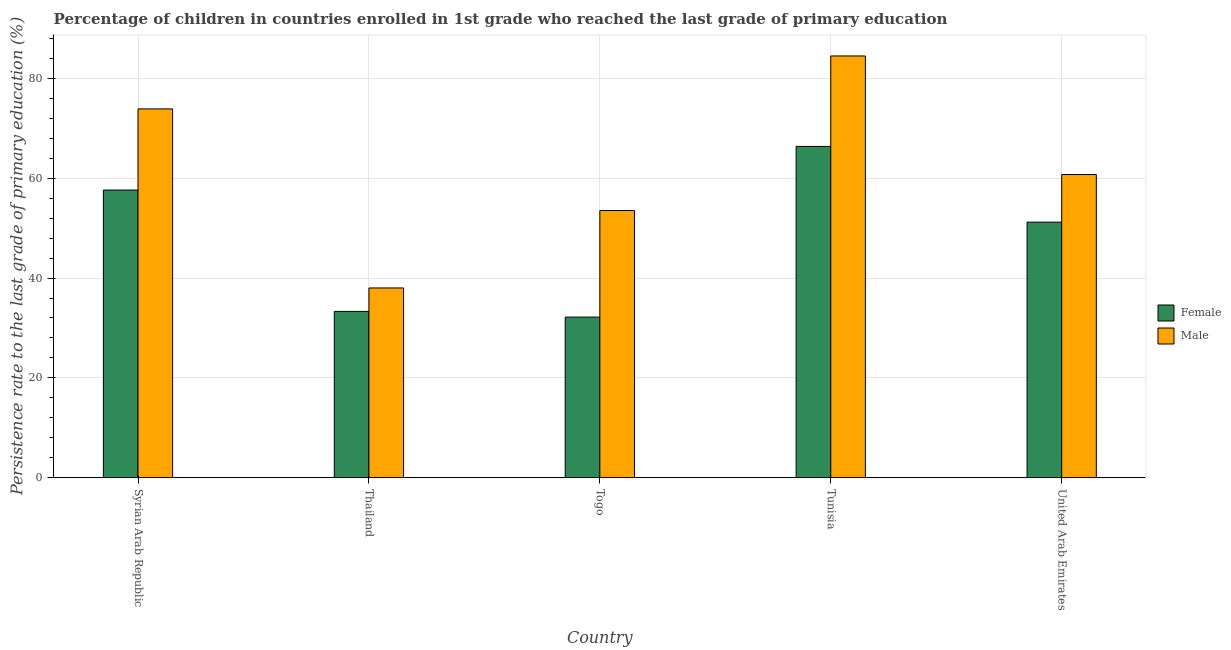How many different coloured bars are there?
Provide a short and direct response. 2. How many groups of bars are there?
Provide a succinct answer. 5. Are the number of bars on each tick of the X-axis equal?
Provide a short and direct response. Yes. What is the label of the 2nd group of bars from the left?
Your answer should be very brief. Thailand. In how many cases, is the number of bars for a given country not equal to the number of legend labels?
Ensure brevity in your answer.  0. What is the persistence rate of female students in Syrian Arab Republic?
Your answer should be very brief. 57.65. Across all countries, what is the maximum persistence rate of female students?
Ensure brevity in your answer.  66.39. Across all countries, what is the minimum persistence rate of female students?
Your answer should be very brief. 32.18. In which country was the persistence rate of male students maximum?
Make the answer very short. Tunisia. In which country was the persistence rate of female students minimum?
Your response must be concise. Togo. What is the total persistence rate of male students in the graph?
Your answer should be very brief. 310.75. What is the difference between the persistence rate of female students in Togo and that in United Arab Emirates?
Your answer should be very brief. -19.03. What is the difference between the persistence rate of female students in United Arab Emirates and the persistence rate of male students in Syrian Arab Republic?
Make the answer very short. -22.7. What is the average persistence rate of female students per country?
Your answer should be compact. 48.15. What is the difference between the persistence rate of female students and persistence rate of male students in United Arab Emirates?
Your response must be concise. -9.54. In how many countries, is the persistence rate of male students greater than 44 %?
Your answer should be compact. 4. What is the ratio of the persistence rate of female students in Togo to that in Tunisia?
Ensure brevity in your answer.  0.48. Is the persistence rate of male students in Togo less than that in Tunisia?
Your response must be concise. Yes. Is the difference between the persistence rate of male students in Togo and Tunisia greater than the difference between the persistence rate of female students in Togo and Tunisia?
Give a very brief answer. Yes. What is the difference between the highest and the second highest persistence rate of male students?
Give a very brief answer. 10.61. What is the difference between the highest and the lowest persistence rate of female students?
Your response must be concise. 34.21. In how many countries, is the persistence rate of female students greater than the average persistence rate of female students taken over all countries?
Offer a very short reply. 3. Is the sum of the persistence rate of female students in Syrian Arab Republic and Thailand greater than the maximum persistence rate of male students across all countries?
Offer a terse response. Yes. How many bars are there?
Provide a short and direct response. 10. Are all the bars in the graph horizontal?
Provide a short and direct response. No. What is the title of the graph?
Your answer should be very brief. Percentage of children in countries enrolled in 1st grade who reached the last grade of primary education. What is the label or title of the X-axis?
Provide a short and direct response. Country. What is the label or title of the Y-axis?
Ensure brevity in your answer.  Persistence rate to the last grade of primary education (%). What is the Persistence rate to the last grade of primary education (%) in Female in Syrian Arab Republic?
Your response must be concise. 57.65. What is the Persistence rate to the last grade of primary education (%) of Male in Syrian Arab Republic?
Your answer should be very brief. 73.91. What is the Persistence rate to the last grade of primary education (%) of Female in Thailand?
Ensure brevity in your answer.  33.32. What is the Persistence rate to the last grade of primary education (%) of Male in Thailand?
Make the answer very short. 38.02. What is the Persistence rate to the last grade of primary education (%) of Female in Togo?
Give a very brief answer. 32.18. What is the Persistence rate to the last grade of primary education (%) in Male in Togo?
Give a very brief answer. 53.54. What is the Persistence rate to the last grade of primary education (%) in Female in Tunisia?
Give a very brief answer. 66.39. What is the Persistence rate to the last grade of primary education (%) in Male in Tunisia?
Your answer should be compact. 84.52. What is the Persistence rate to the last grade of primary education (%) in Female in United Arab Emirates?
Your answer should be compact. 51.21. What is the Persistence rate to the last grade of primary education (%) in Male in United Arab Emirates?
Your answer should be very brief. 60.76. Across all countries, what is the maximum Persistence rate to the last grade of primary education (%) of Female?
Ensure brevity in your answer.  66.39. Across all countries, what is the maximum Persistence rate to the last grade of primary education (%) in Male?
Provide a succinct answer. 84.52. Across all countries, what is the minimum Persistence rate to the last grade of primary education (%) in Female?
Your response must be concise. 32.18. Across all countries, what is the minimum Persistence rate to the last grade of primary education (%) in Male?
Provide a succinct answer. 38.02. What is the total Persistence rate to the last grade of primary education (%) of Female in the graph?
Your answer should be very brief. 240.76. What is the total Persistence rate to the last grade of primary education (%) in Male in the graph?
Make the answer very short. 310.75. What is the difference between the Persistence rate to the last grade of primary education (%) of Female in Syrian Arab Republic and that in Thailand?
Ensure brevity in your answer.  24.33. What is the difference between the Persistence rate to the last grade of primary education (%) of Male in Syrian Arab Republic and that in Thailand?
Keep it short and to the point. 35.89. What is the difference between the Persistence rate to the last grade of primary education (%) of Female in Syrian Arab Republic and that in Togo?
Ensure brevity in your answer.  25.47. What is the difference between the Persistence rate to the last grade of primary education (%) in Male in Syrian Arab Republic and that in Togo?
Offer a very short reply. 20.37. What is the difference between the Persistence rate to the last grade of primary education (%) of Female in Syrian Arab Republic and that in Tunisia?
Provide a succinct answer. -8.75. What is the difference between the Persistence rate to the last grade of primary education (%) in Male in Syrian Arab Republic and that in Tunisia?
Ensure brevity in your answer.  -10.61. What is the difference between the Persistence rate to the last grade of primary education (%) of Female in Syrian Arab Republic and that in United Arab Emirates?
Your response must be concise. 6.43. What is the difference between the Persistence rate to the last grade of primary education (%) in Male in Syrian Arab Republic and that in United Arab Emirates?
Offer a terse response. 13.16. What is the difference between the Persistence rate to the last grade of primary education (%) of Female in Thailand and that in Togo?
Your answer should be compact. 1.14. What is the difference between the Persistence rate to the last grade of primary education (%) of Male in Thailand and that in Togo?
Offer a very short reply. -15.52. What is the difference between the Persistence rate to the last grade of primary education (%) in Female in Thailand and that in Tunisia?
Your response must be concise. -33.07. What is the difference between the Persistence rate to the last grade of primary education (%) of Male in Thailand and that in Tunisia?
Your response must be concise. -46.5. What is the difference between the Persistence rate to the last grade of primary education (%) of Female in Thailand and that in United Arab Emirates?
Ensure brevity in your answer.  -17.89. What is the difference between the Persistence rate to the last grade of primary education (%) in Male in Thailand and that in United Arab Emirates?
Keep it short and to the point. -22.74. What is the difference between the Persistence rate to the last grade of primary education (%) in Female in Togo and that in Tunisia?
Your answer should be compact. -34.21. What is the difference between the Persistence rate to the last grade of primary education (%) of Male in Togo and that in Tunisia?
Provide a succinct answer. -30.98. What is the difference between the Persistence rate to the last grade of primary education (%) in Female in Togo and that in United Arab Emirates?
Offer a terse response. -19.03. What is the difference between the Persistence rate to the last grade of primary education (%) in Male in Togo and that in United Arab Emirates?
Your answer should be compact. -7.21. What is the difference between the Persistence rate to the last grade of primary education (%) in Female in Tunisia and that in United Arab Emirates?
Ensure brevity in your answer.  15.18. What is the difference between the Persistence rate to the last grade of primary education (%) of Male in Tunisia and that in United Arab Emirates?
Offer a very short reply. 23.77. What is the difference between the Persistence rate to the last grade of primary education (%) in Female in Syrian Arab Republic and the Persistence rate to the last grade of primary education (%) in Male in Thailand?
Offer a terse response. 19.63. What is the difference between the Persistence rate to the last grade of primary education (%) of Female in Syrian Arab Republic and the Persistence rate to the last grade of primary education (%) of Male in Togo?
Keep it short and to the point. 4.11. What is the difference between the Persistence rate to the last grade of primary education (%) in Female in Syrian Arab Republic and the Persistence rate to the last grade of primary education (%) in Male in Tunisia?
Ensure brevity in your answer.  -26.88. What is the difference between the Persistence rate to the last grade of primary education (%) in Female in Syrian Arab Republic and the Persistence rate to the last grade of primary education (%) in Male in United Arab Emirates?
Provide a short and direct response. -3.11. What is the difference between the Persistence rate to the last grade of primary education (%) in Female in Thailand and the Persistence rate to the last grade of primary education (%) in Male in Togo?
Offer a very short reply. -20.22. What is the difference between the Persistence rate to the last grade of primary education (%) in Female in Thailand and the Persistence rate to the last grade of primary education (%) in Male in Tunisia?
Give a very brief answer. -51.2. What is the difference between the Persistence rate to the last grade of primary education (%) in Female in Thailand and the Persistence rate to the last grade of primary education (%) in Male in United Arab Emirates?
Offer a very short reply. -27.43. What is the difference between the Persistence rate to the last grade of primary education (%) of Female in Togo and the Persistence rate to the last grade of primary education (%) of Male in Tunisia?
Provide a short and direct response. -52.34. What is the difference between the Persistence rate to the last grade of primary education (%) of Female in Togo and the Persistence rate to the last grade of primary education (%) of Male in United Arab Emirates?
Keep it short and to the point. -28.58. What is the difference between the Persistence rate to the last grade of primary education (%) in Female in Tunisia and the Persistence rate to the last grade of primary education (%) in Male in United Arab Emirates?
Provide a succinct answer. 5.64. What is the average Persistence rate to the last grade of primary education (%) in Female per country?
Give a very brief answer. 48.15. What is the average Persistence rate to the last grade of primary education (%) in Male per country?
Your answer should be compact. 62.15. What is the difference between the Persistence rate to the last grade of primary education (%) in Female and Persistence rate to the last grade of primary education (%) in Male in Syrian Arab Republic?
Provide a succinct answer. -16.26. What is the difference between the Persistence rate to the last grade of primary education (%) of Female and Persistence rate to the last grade of primary education (%) of Male in Thailand?
Provide a short and direct response. -4.7. What is the difference between the Persistence rate to the last grade of primary education (%) in Female and Persistence rate to the last grade of primary education (%) in Male in Togo?
Offer a very short reply. -21.36. What is the difference between the Persistence rate to the last grade of primary education (%) in Female and Persistence rate to the last grade of primary education (%) in Male in Tunisia?
Offer a very short reply. -18.13. What is the difference between the Persistence rate to the last grade of primary education (%) in Female and Persistence rate to the last grade of primary education (%) in Male in United Arab Emirates?
Ensure brevity in your answer.  -9.54. What is the ratio of the Persistence rate to the last grade of primary education (%) in Female in Syrian Arab Republic to that in Thailand?
Provide a succinct answer. 1.73. What is the ratio of the Persistence rate to the last grade of primary education (%) of Male in Syrian Arab Republic to that in Thailand?
Give a very brief answer. 1.94. What is the ratio of the Persistence rate to the last grade of primary education (%) in Female in Syrian Arab Republic to that in Togo?
Offer a very short reply. 1.79. What is the ratio of the Persistence rate to the last grade of primary education (%) in Male in Syrian Arab Republic to that in Togo?
Ensure brevity in your answer.  1.38. What is the ratio of the Persistence rate to the last grade of primary education (%) of Female in Syrian Arab Republic to that in Tunisia?
Make the answer very short. 0.87. What is the ratio of the Persistence rate to the last grade of primary education (%) of Male in Syrian Arab Republic to that in Tunisia?
Provide a succinct answer. 0.87. What is the ratio of the Persistence rate to the last grade of primary education (%) of Female in Syrian Arab Republic to that in United Arab Emirates?
Offer a terse response. 1.13. What is the ratio of the Persistence rate to the last grade of primary education (%) of Male in Syrian Arab Republic to that in United Arab Emirates?
Offer a very short reply. 1.22. What is the ratio of the Persistence rate to the last grade of primary education (%) of Female in Thailand to that in Togo?
Make the answer very short. 1.04. What is the ratio of the Persistence rate to the last grade of primary education (%) of Male in Thailand to that in Togo?
Give a very brief answer. 0.71. What is the ratio of the Persistence rate to the last grade of primary education (%) in Female in Thailand to that in Tunisia?
Make the answer very short. 0.5. What is the ratio of the Persistence rate to the last grade of primary education (%) in Male in Thailand to that in Tunisia?
Your response must be concise. 0.45. What is the ratio of the Persistence rate to the last grade of primary education (%) of Female in Thailand to that in United Arab Emirates?
Your answer should be very brief. 0.65. What is the ratio of the Persistence rate to the last grade of primary education (%) of Male in Thailand to that in United Arab Emirates?
Keep it short and to the point. 0.63. What is the ratio of the Persistence rate to the last grade of primary education (%) of Female in Togo to that in Tunisia?
Provide a short and direct response. 0.48. What is the ratio of the Persistence rate to the last grade of primary education (%) in Male in Togo to that in Tunisia?
Offer a terse response. 0.63. What is the ratio of the Persistence rate to the last grade of primary education (%) in Female in Togo to that in United Arab Emirates?
Keep it short and to the point. 0.63. What is the ratio of the Persistence rate to the last grade of primary education (%) of Male in Togo to that in United Arab Emirates?
Provide a short and direct response. 0.88. What is the ratio of the Persistence rate to the last grade of primary education (%) in Female in Tunisia to that in United Arab Emirates?
Offer a terse response. 1.3. What is the ratio of the Persistence rate to the last grade of primary education (%) in Male in Tunisia to that in United Arab Emirates?
Ensure brevity in your answer.  1.39. What is the difference between the highest and the second highest Persistence rate to the last grade of primary education (%) in Female?
Give a very brief answer. 8.75. What is the difference between the highest and the second highest Persistence rate to the last grade of primary education (%) of Male?
Provide a succinct answer. 10.61. What is the difference between the highest and the lowest Persistence rate to the last grade of primary education (%) in Female?
Offer a terse response. 34.21. What is the difference between the highest and the lowest Persistence rate to the last grade of primary education (%) of Male?
Provide a succinct answer. 46.5. 